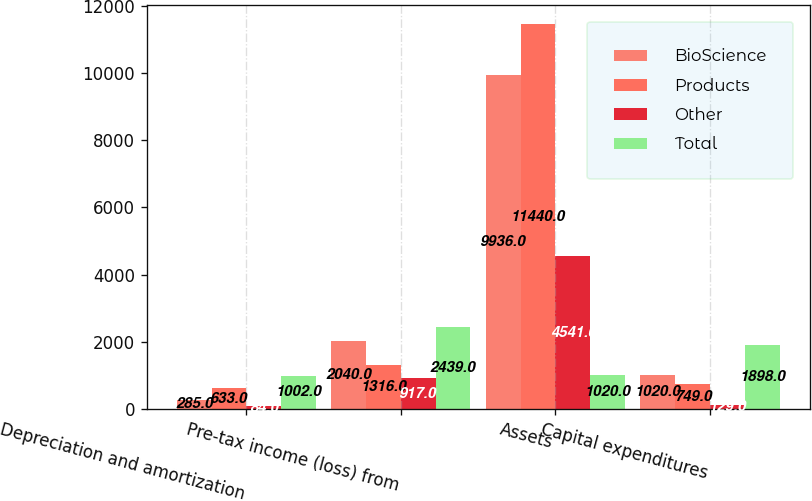Convert chart to OTSL. <chart><loc_0><loc_0><loc_500><loc_500><stacked_bar_chart><ecel><fcel>Depreciation and amortization<fcel>Pre-tax income (loss) from<fcel>Assets<fcel>Capital expenditures<nl><fcel>BioScience<fcel>285<fcel>2040<fcel>9936<fcel>1020<nl><fcel>Products<fcel>633<fcel>1316<fcel>11440<fcel>749<nl><fcel>Other<fcel>84<fcel>917<fcel>4541<fcel>129<nl><fcel>Total<fcel>1002<fcel>2439<fcel>1020<fcel>1898<nl></chart> 